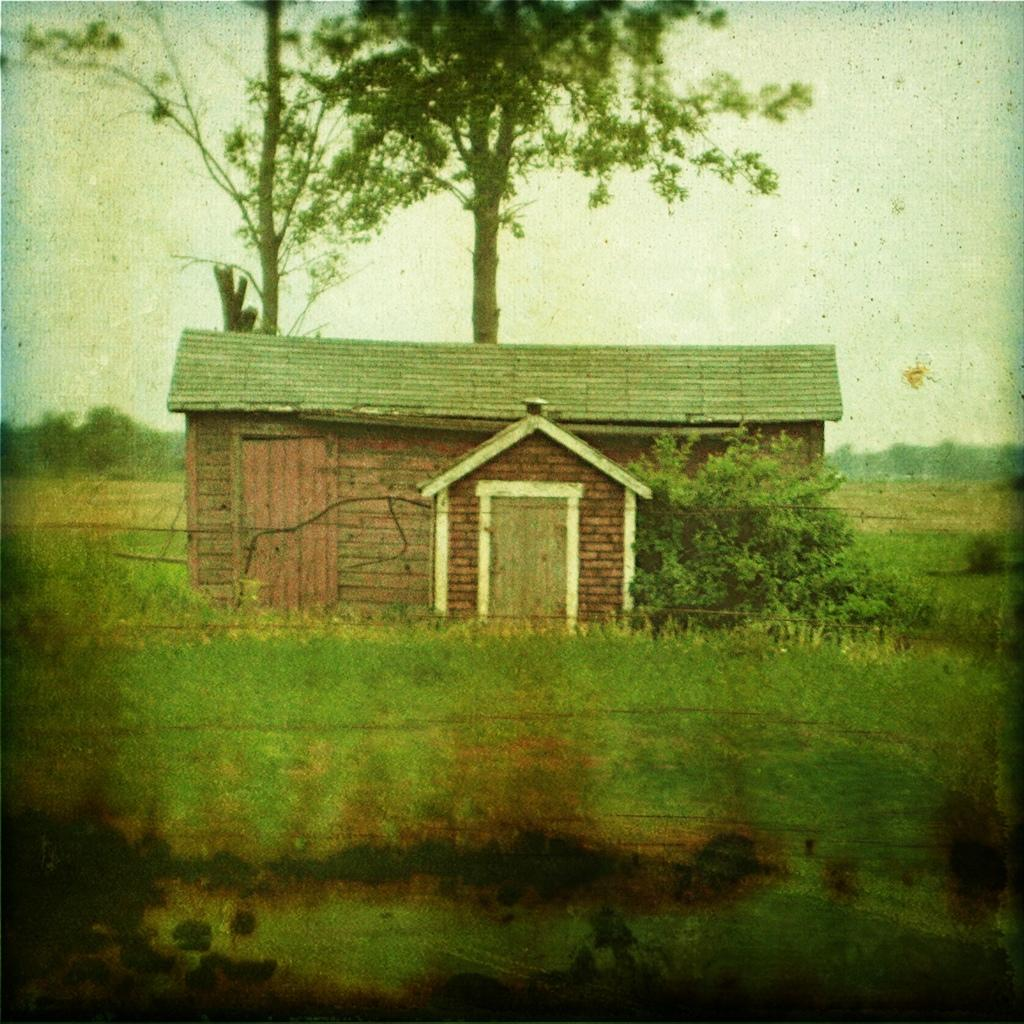What is the main subject in the center of the image? There is a house in the center of the image. What can be seen surrounding the house? There is greenery around the house. How many frogs are sitting on the chimney of the house in the image? There are no frogs present in the image, and therefore no frogs can be seen sitting on the chimney. 